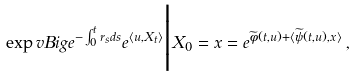Convert formula to latex. <formula><loc_0><loc_0><loc_500><loc_500>\exp v B i g { e ^ { - \int _ { 0 } ^ { t } r _ { s } d s } e ^ { \langle u , X _ { t } \rangle } \Big | X _ { 0 } = x } = e ^ { \widetilde { \phi } ( t , u ) + \langle \widetilde { \psi } ( t , u ) , x \rangle } \, ,</formula> 